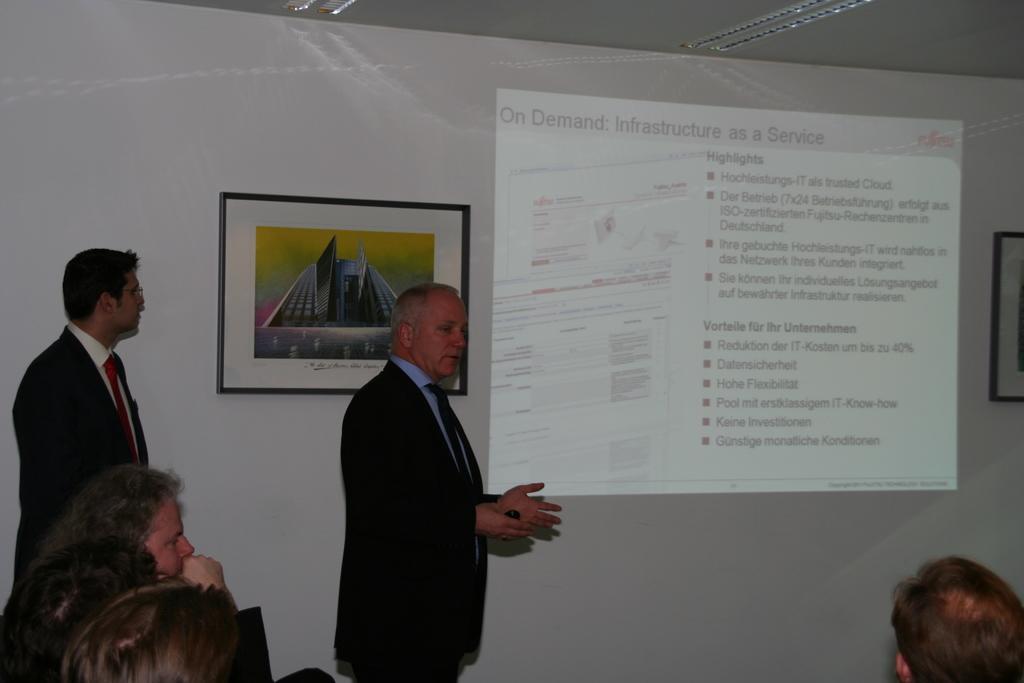Could you give a brief overview of what you see in this image? On the left side I can see two men are standing. One man is talking something. At the back of this man I can see a wall on which two frames are attached and also I can see screen. This man is looking at the screen. At the bottom of the image I can see few persons. On the top there are some lights. 